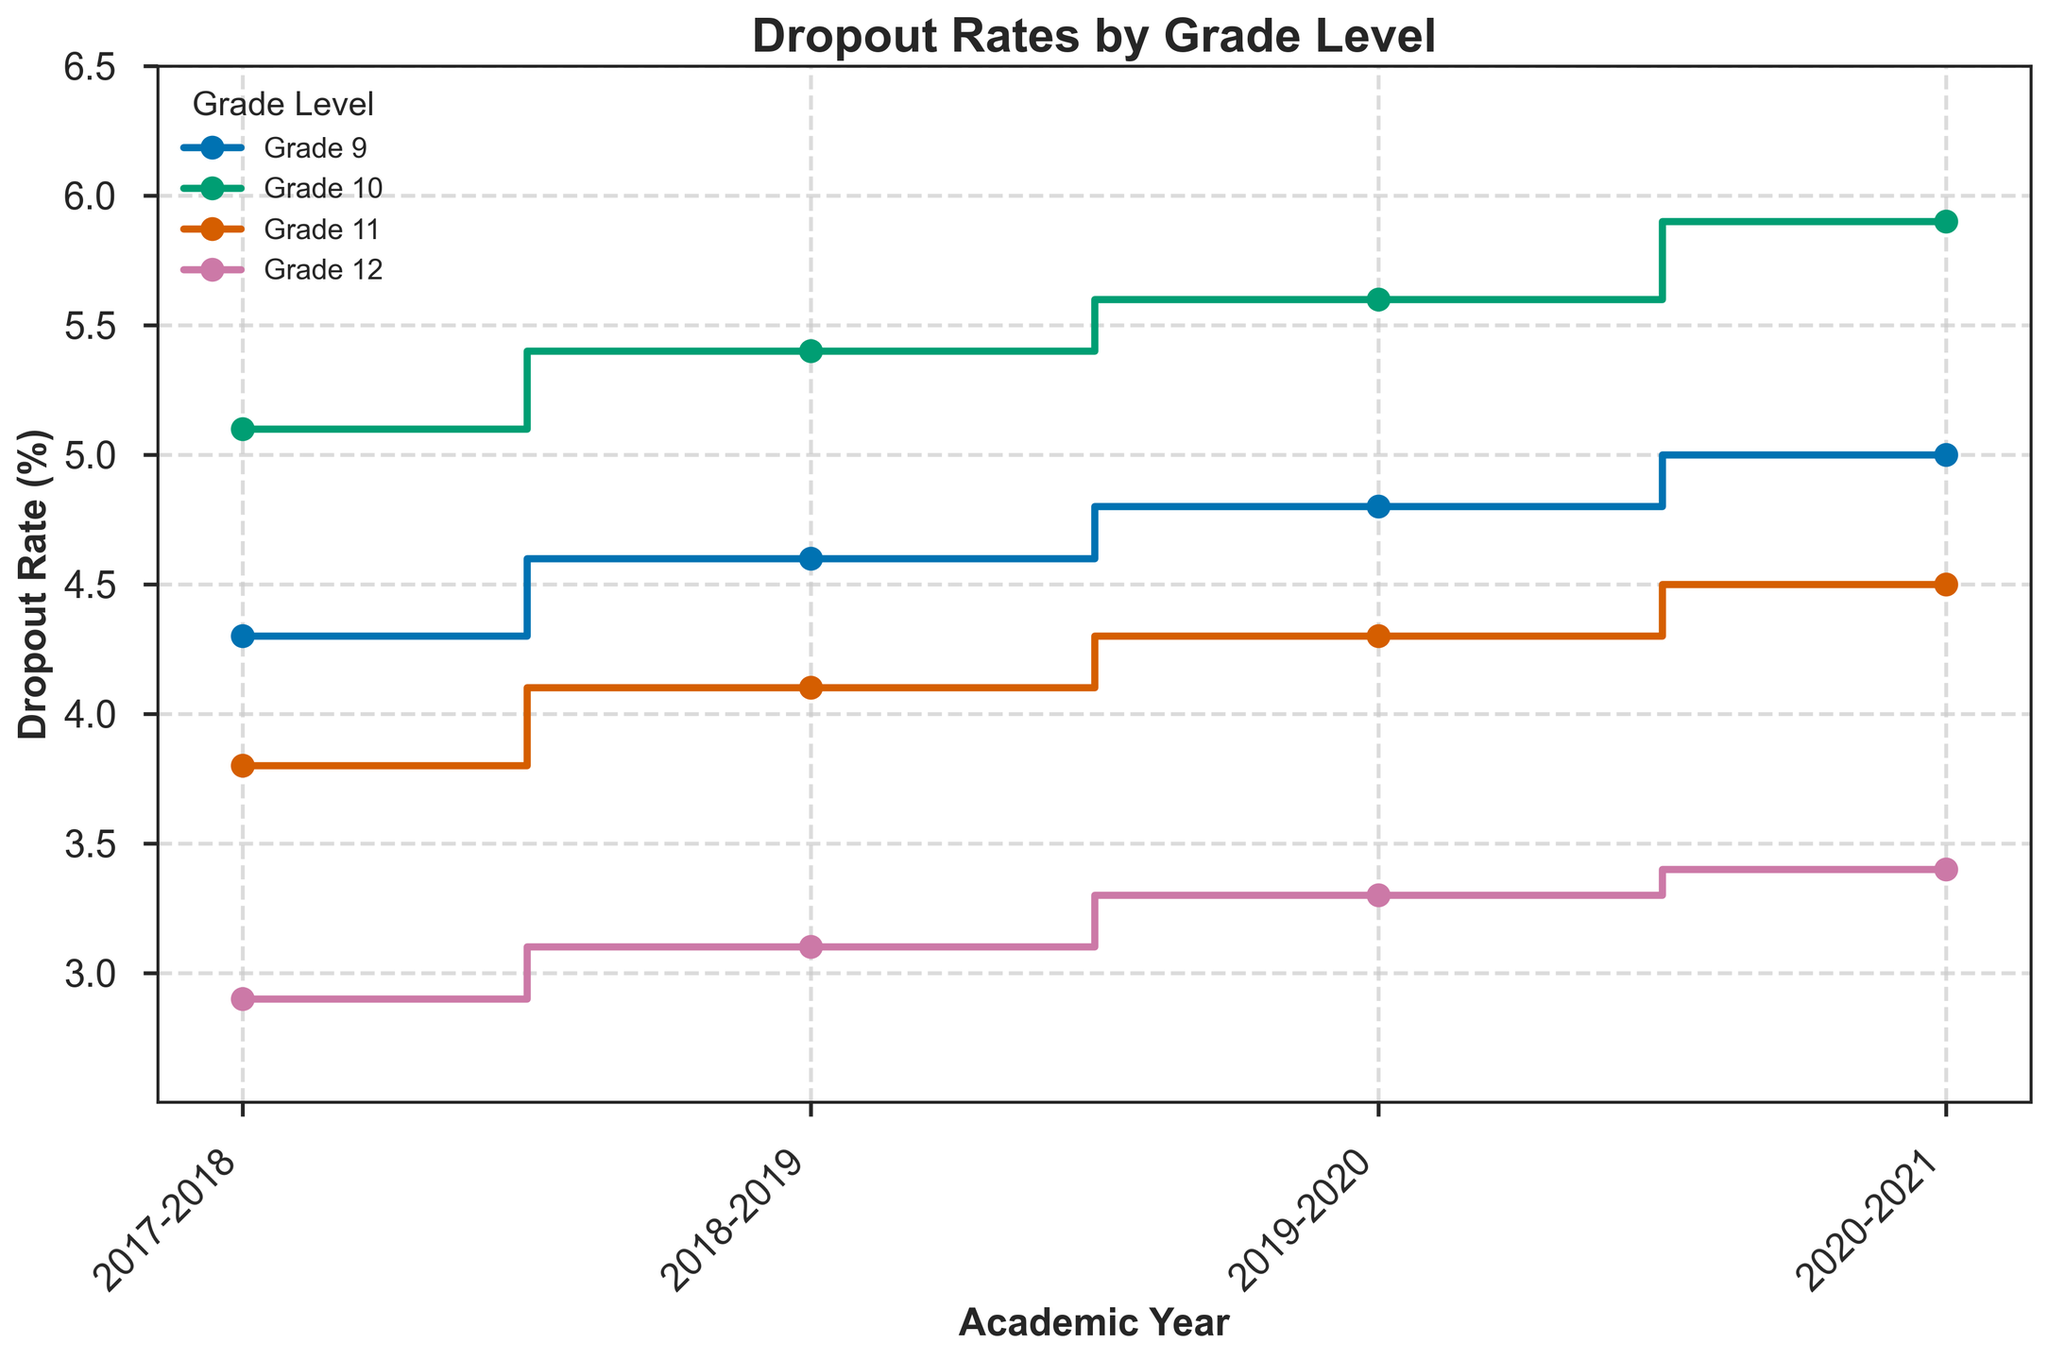What's the dropout rate for Grade 12 in the 2017-2018 academic year? First, locate the "2017-2018" academic year on the x-axis. Then, find the line corresponding to Grade 12 and trace it to the y-axis to find the dropout rate. The dropout rate for Grade 12 in 2017-2018 is 2.9%.
Answer: 2.9% Which grade had the highest dropout rate in the 2020-2021 academic year? First, locate the "2020-2021" academic year on the x-axis. Then, compare the dropout rates for all grade levels in that year by tracing their lines up to the y-axis. Grade 10 had the highest dropout rate at 5.9%.
Answer: Grade 10 What is the average dropout rate for Grade 9 from 2017-2021? Take the dropout rates for Grade 9 across the academic years: 4.3, 4.6, 4.8, and 5.0. Sum these rates (4.3 + 4.6 + 4.8 + 5.0 = 18.7) and divide by 4 (number of years) to get the average: 18.7 / 4 = 4.675.
Answer: 4.675% How does the dropout rate for Grade 11 in 2019-2020 compare to the same grade in the previous year? Locate the data points for Grade 11 in both the 2019-2020 and 2018-2019 academic years. In 2018-2019, the rate is 4.1%, and in 2019-2020, it is 4.3%. The 2019-2020 rate is higher than the 2018-2019 rate.
Answer: Higher What trend do you observe in the dropout rate for Grade 10 from 2017-2021? Observe the changes in the dropout rate for Grade 10 across the years 2017-2021. The dropout rates increase from 5.1% in 2017-2018 to 5.9% in 2020-2021, showing an upward trend.
Answer: Upward trend Which academic year had the lowest overall dropout rate for Grade 12? Compare the dropout rates for Grade 12 across all academic years: 2.9% (2017-2018), 3.1% (2018-2019), 3.3% (2019-2020), and 3.4% (2020-2021). The lowest rate is 2.9% in 2017-2018.
Answer: 2017-2018 By how much did the dropout rate for Grade 9 increase from 2017-2018 to 2020-2021? Subtract the dropout rate for Grade 9 in 2017-2018 (4.3%) from the dropout rate in 2020-2021 (5.0%). The increase is 5.0% - 4.3% = 0.7%.
Answer: 0.7% Which grade level's dropout rate shows the most stability across the academic years? Examine the lines for each grade level and compare the variations in their dropout rates across the years. Grade 12 has the least variation in rates, ranging from 2.9% to 3.4%.
Answer: Grade 12 What could be inferred from the dropout rate trend for Grade 11 from 2017-2021? Analyze the line for Grade 11, observing the rates: 3.8%, 4.1%, 4.3%, and 4.5%. The small but consistent increase indicates a rising dropout rate over the years.
Answer: Rising trend Compare the dropout rates of Grade 9 and Grade 10 in the 2019-2020 academic year. Find the data points for both grades in the 2019-2020 academic year. Grade 9 has a dropout rate of 4.8%, while Grade 10 has a rate of 5.6%. Grade 10 has a higher rate than Grade 9.
Answer: Grade 10 has a higher rate 